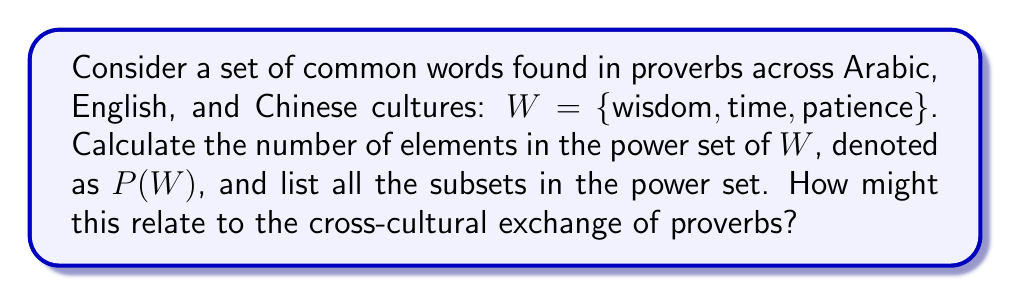Could you help me with this problem? To solve this problem, we need to understand the concept of a power set and apply it to the given set of words.

1. Power set definition:
   The power set of a set $S$, denoted as $P(S)$, is the set of all possible subsets of $S$, including the empty set and $S$ itself.

2. Number of elements in a power set:
   For a set with $n$ elements, the number of elements in its power set is $2^n$.

3. In this case:
   $W = \{\text{wisdom}, \text{time}, \text{patience}\}$
   $|W| = 3$ (the set has 3 elements)

4. Calculate the number of elements in $P(W)$:
   $|P(W)| = 2^{|W|} = 2^3 = 8$

5. List all subsets in $P(W)$:
   - $\emptyset$ (empty set)
   - $\{\text{wisdom}\}$
   - $\{\text{time}\}$
   - $\{\text{patience}\}$
   - $\{\text{wisdom}, \text{time}\}$
   - $\{\text{wisdom}, \text{patience}\}$
   - $\{\text{time}, \text{patience}\}$
   - $\{\text{wisdom}, \text{time}, \text{patience}\}$

6. Relation to cross-cultural exchange of proverbs:
   The power set represents all possible combinations of these common words found in proverbs across Arabic, English, and Chinese cultures. Each subset could potentially represent a theme or concept shared among these cultures. For example, $\{\text{wisdom}, \text{time}\}$ might represent proverbs that link wisdom with the passage of time, while $\{\text{patience}, \text{time}\}$ could relate to proverbs about the virtue of patience over time. This analysis can help identify common themes and variations in proverbs across these cultures, facilitating the study of cross-cultural wisdom and linguistic exchange.
Answer: The power set $P(W)$ has $2^3 = 8$ elements, consisting of all possible subsets of $W$, including the empty set and $W$ itself. 